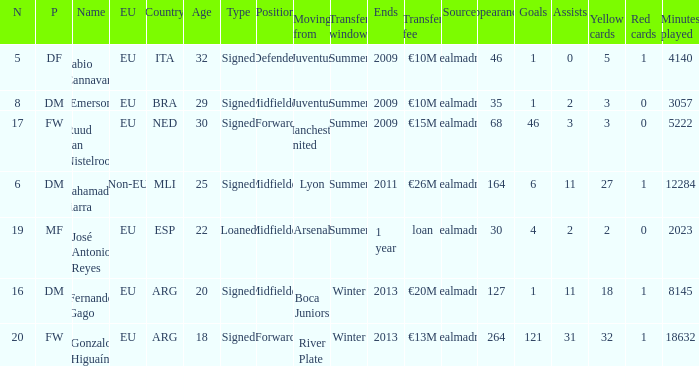What is the EU status of ESP? EU. 